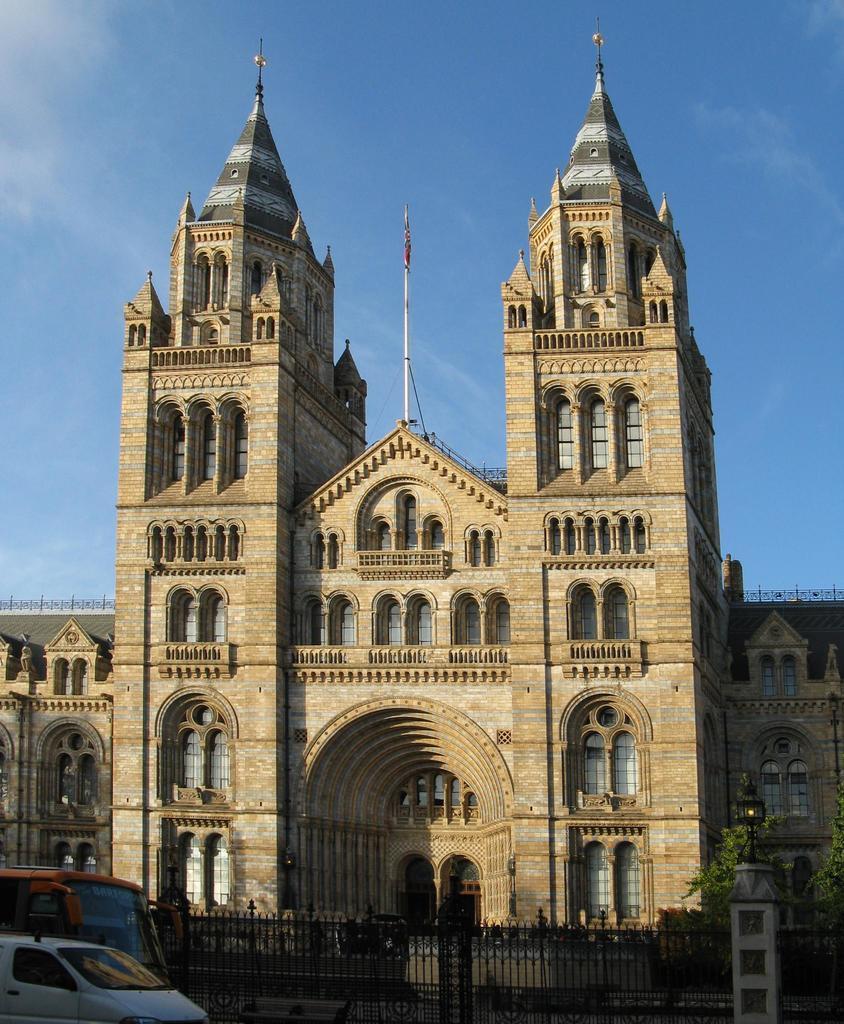In one or two sentences, can you explain what this image depicts? In this image I can see vehicles, gate, trees on the right and a building at the back. There is sky at the top. 